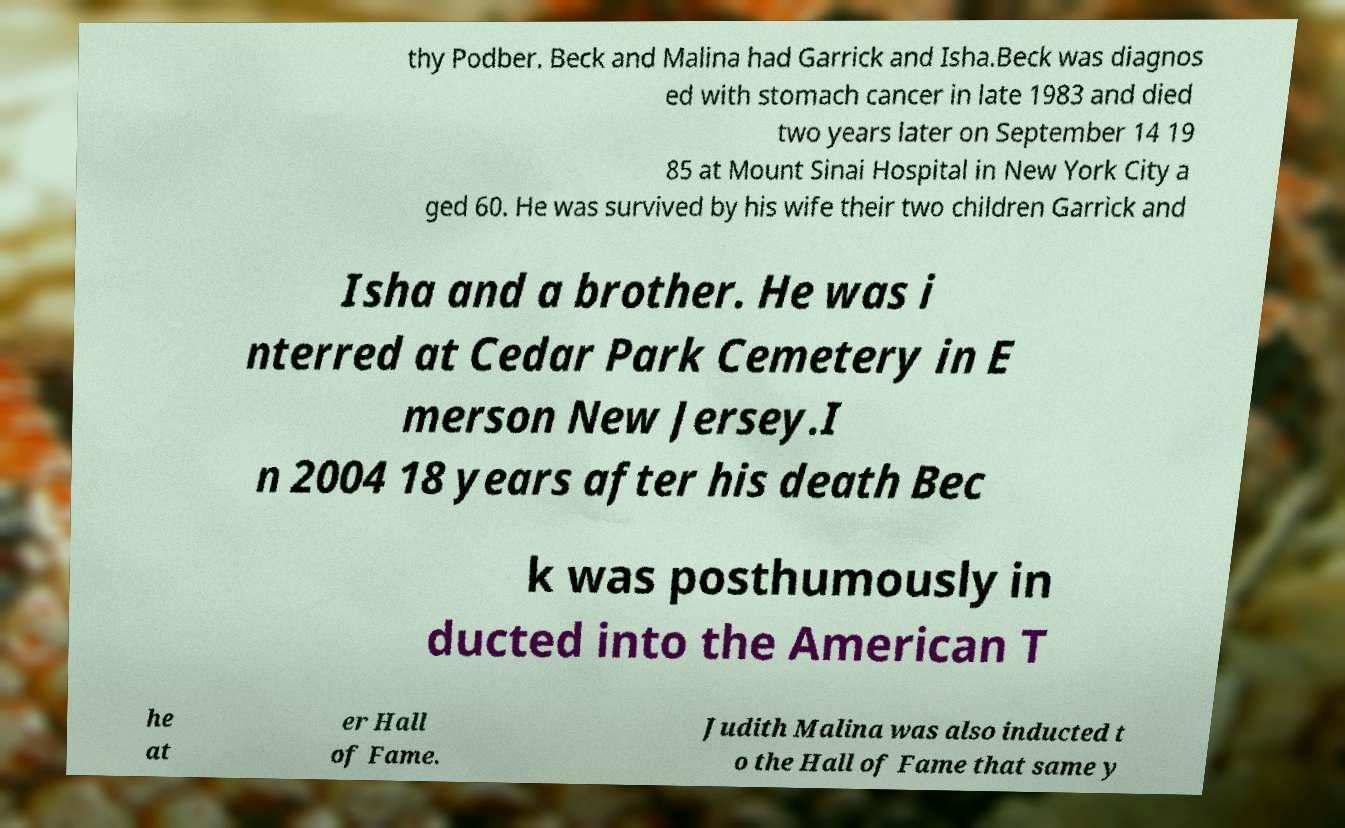For documentation purposes, I need the text within this image transcribed. Could you provide that? thy Podber. Beck and Malina had Garrick and Isha.Beck was diagnos ed with stomach cancer in late 1983 and died two years later on September 14 19 85 at Mount Sinai Hospital in New York City a ged 60. He was survived by his wife their two children Garrick and Isha and a brother. He was i nterred at Cedar Park Cemetery in E merson New Jersey.I n 2004 18 years after his death Bec k was posthumously in ducted into the American T he at er Hall of Fame. Judith Malina was also inducted t o the Hall of Fame that same y 